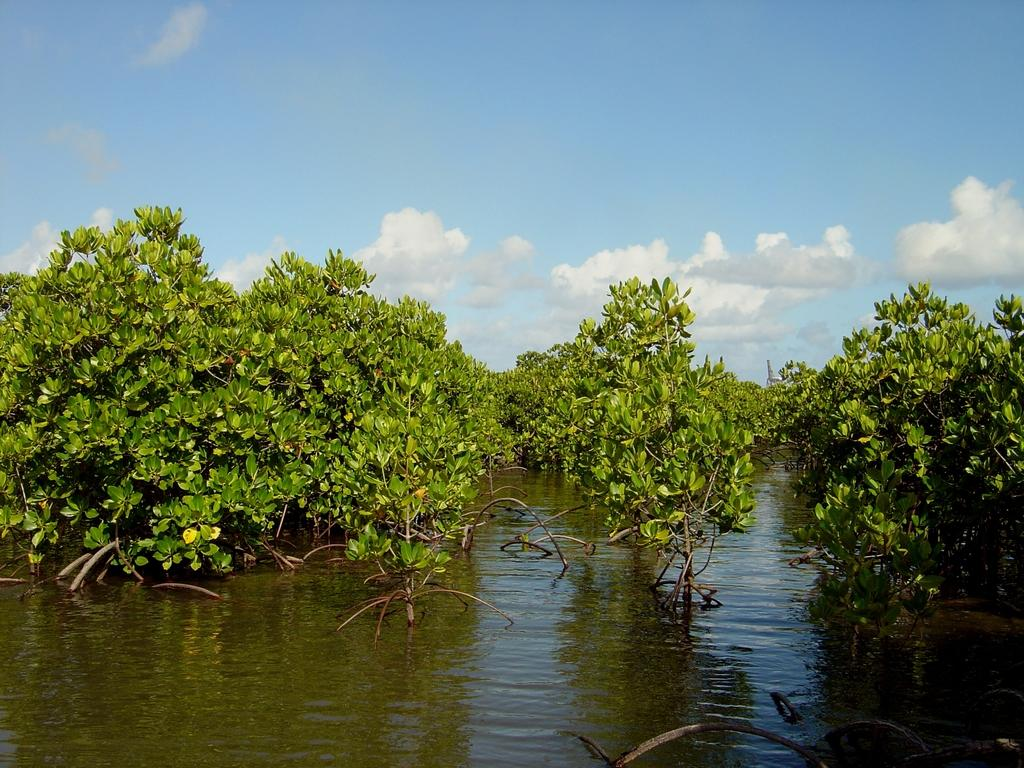What type of vegetation can be seen in the image? There are trees visible in the image. Where are the trees located? The trees are on water. What is visible at the top of the image? The sky is visible at the top of the image. Can you hear the cat's ear in the image? There is no cat or ear present in the image; it features trees on water and a visible sky. 